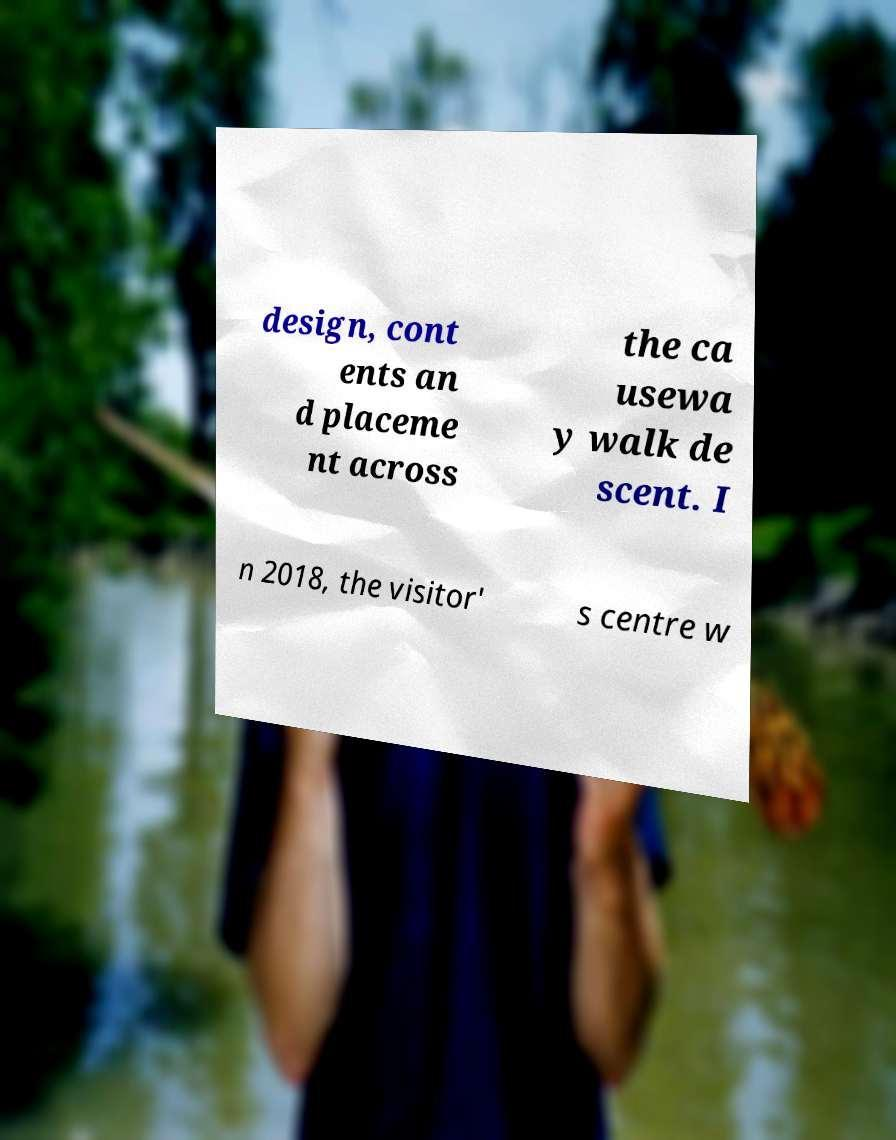Can you read and provide the text displayed in the image?This photo seems to have some interesting text. Can you extract and type it out for me? design, cont ents an d placeme nt across the ca usewa y walk de scent. I n 2018, the visitor' s centre w 